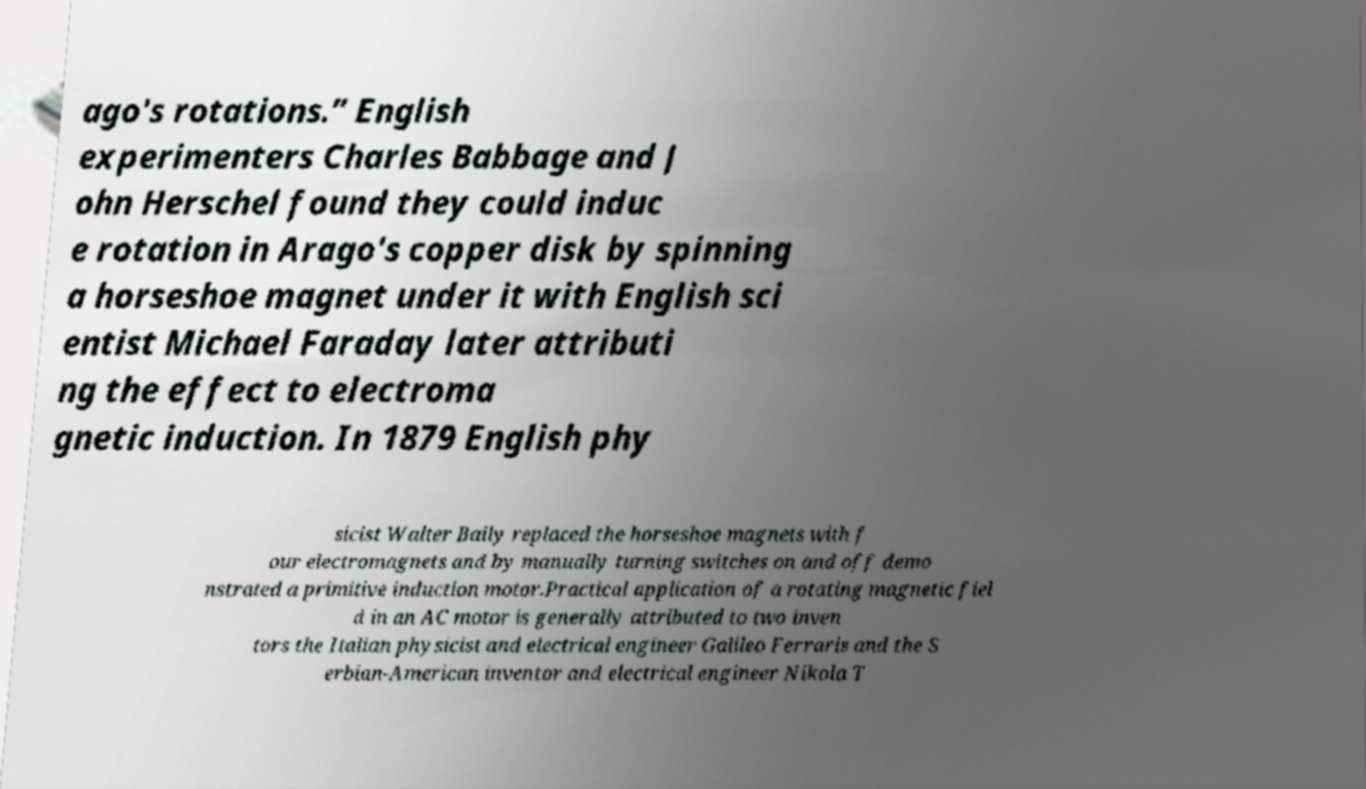Please read and relay the text visible in this image. What does it say? ago's rotations.” English experimenters Charles Babbage and J ohn Herschel found they could induc e rotation in Arago's copper disk by spinning a horseshoe magnet under it with English sci entist Michael Faraday later attributi ng the effect to electroma gnetic induction. In 1879 English phy sicist Walter Baily replaced the horseshoe magnets with f our electromagnets and by manually turning switches on and off demo nstrated a primitive induction motor.Practical application of a rotating magnetic fiel d in an AC motor is generally attributed to two inven tors the Italian physicist and electrical engineer Galileo Ferraris and the S erbian-American inventor and electrical engineer Nikola T 